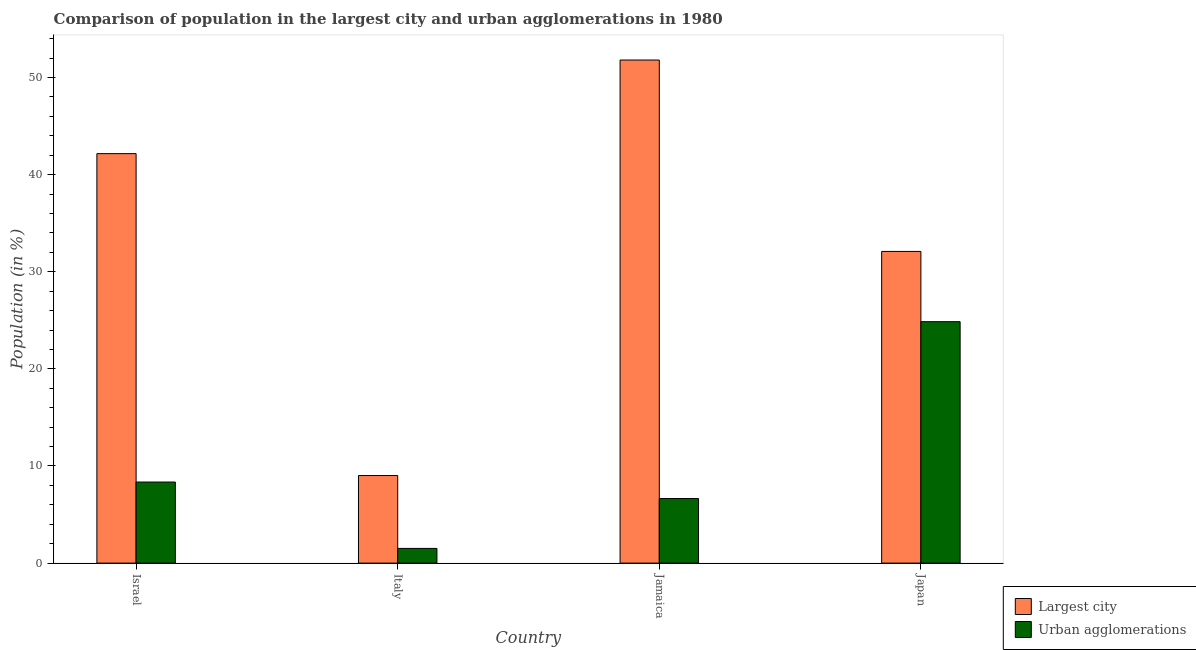How many different coloured bars are there?
Keep it short and to the point. 2. What is the label of the 1st group of bars from the left?
Provide a short and direct response. Israel. In how many cases, is the number of bars for a given country not equal to the number of legend labels?
Give a very brief answer. 0. What is the population in urban agglomerations in Jamaica?
Offer a very short reply. 6.65. Across all countries, what is the maximum population in urban agglomerations?
Offer a terse response. 24.86. Across all countries, what is the minimum population in the largest city?
Provide a succinct answer. 9.02. In which country was the population in urban agglomerations maximum?
Your answer should be compact. Japan. What is the total population in urban agglomerations in the graph?
Your answer should be very brief. 41.36. What is the difference between the population in the largest city in Israel and that in Jamaica?
Offer a very short reply. -9.64. What is the difference between the population in urban agglomerations in Italy and the population in the largest city in Japan?
Offer a very short reply. -30.58. What is the average population in urban agglomerations per country?
Your response must be concise. 10.34. What is the difference between the population in the largest city and population in urban agglomerations in Italy?
Your answer should be compact. 7.5. In how many countries, is the population in the largest city greater than 20 %?
Ensure brevity in your answer.  3. What is the ratio of the population in urban agglomerations in Italy to that in Jamaica?
Offer a very short reply. 0.23. What is the difference between the highest and the second highest population in urban agglomerations?
Your response must be concise. 16.51. What is the difference between the highest and the lowest population in urban agglomerations?
Provide a short and direct response. 23.35. Is the sum of the population in urban agglomerations in Israel and Japan greater than the maximum population in the largest city across all countries?
Provide a succinct answer. No. What does the 1st bar from the left in Italy represents?
Your answer should be compact. Largest city. What does the 1st bar from the right in Jamaica represents?
Give a very brief answer. Urban agglomerations. How many countries are there in the graph?
Your answer should be compact. 4. Are the values on the major ticks of Y-axis written in scientific E-notation?
Provide a succinct answer. No. Does the graph contain grids?
Your answer should be very brief. No. How many legend labels are there?
Provide a succinct answer. 2. What is the title of the graph?
Your response must be concise. Comparison of population in the largest city and urban agglomerations in 1980. Does "Secondary" appear as one of the legend labels in the graph?
Give a very brief answer. No. What is the label or title of the X-axis?
Make the answer very short. Country. What is the Population (in %) of Largest city in Israel?
Provide a short and direct response. 42.16. What is the Population (in %) in Urban agglomerations in Israel?
Give a very brief answer. 8.35. What is the Population (in %) in Largest city in Italy?
Offer a very short reply. 9.02. What is the Population (in %) in Urban agglomerations in Italy?
Your answer should be very brief. 1.51. What is the Population (in %) of Largest city in Jamaica?
Provide a succinct answer. 51.8. What is the Population (in %) of Urban agglomerations in Jamaica?
Your answer should be compact. 6.65. What is the Population (in %) in Largest city in Japan?
Keep it short and to the point. 32.09. What is the Population (in %) of Urban agglomerations in Japan?
Provide a short and direct response. 24.86. Across all countries, what is the maximum Population (in %) in Largest city?
Keep it short and to the point. 51.8. Across all countries, what is the maximum Population (in %) in Urban agglomerations?
Your answer should be compact. 24.86. Across all countries, what is the minimum Population (in %) in Largest city?
Your answer should be very brief. 9.02. Across all countries, what is the minimum Population (in %) of Urban agglomerations?
Provide a short and direct response. 1.51. What is the total Population (in %) of Largest city in the graph?
Provide a short and direct response. 135.07. What is the total Population (in %) of Urban agglomerations in the graph?
Ensure brevity in your answer.  41.36. What is the difference between the Population (in %) in Largest city in Israel and that in Italy?
Keep it short and to the point. 33.15. What is the difference between the Population (in %) in Urban agglomerations in Israel and that in Italy?
Provide a succinct answer. 6.83. What is the difference between the Population (in %) of Largest city in Israel and that in Jamaica?
Ensure brevity in your answer.  -9.64. What is the difference between the Population (in %) in Urban agglomerations in Israel and that in Jamaica?
Keep it short and to the point. 1.7. What is the difference between the Population (in %) of Largest city in Israel and that in Japan?
Offer a terse response. 10.07. What is the difference between the Population (in %) in Urban agglomerations in Israel and that in Japan?
Give a very brief answer. -16.51. What is the difference between the Population (in %) of Largest city in Italy and that in Jamaica?
Offer a very short reply. -42.78. What is the difference between the Population (in %) in Urban agglomerations in Italy and that in Jamaica?
Your answer should be compact. -5.14. What is the difference between the Population (in %) in Largest city in Italy and that in Japan?
Provide a succinct answer. -23.08. What is the difference between the Population (in %) of Urban agglomerations in Italy and that in Japan?
Give a very brief answer. -23.35. What is the difference between the Population (in %) in Largest city in Jamaica and that in Japan?
Ensure brevity in your answer.  19.71. What is the difference between the Population (in %) of Urban agglomerations in Jamaica and that in Japan?
Provide a succinct answer. -18.21. What is the difference between the Population (in %) in Largest city in Israel and the Population (in %) in Urban agglomerations in Italy?
Provide a short and direct response. 40.65. What is the difference between the Population (in %) of Largest city in Israel and the Population (in %) of Urban agglomerations in Jamaica?
Keep it short and to the point. 35.51. What is the difference between the Population (in %) in Largest city in Israel and the Population (in %) in Urban agglomerations in Japan?
Your response must be concise. 17.3. What is the difference between the Population (in %) of Largest city in Italy and the Population (in %) of Urban agglomerations in Jamaica?
Offer a terse response. 2.37. What is the difference between the Population (in %) in Largest city in Italy and the Population (in %) in Urban agglomerations in Japan?
Give a very brief answer. -15.84. What is the difference between the Population (in %) of Largest city in Jamaica and the Population (in %) of Urban agglomerations in Japan?
Offer a terse response. 26.94. What is the average Population (in %) in Largest city per country?
Your answer should be compact. 33.77. What is the average Population (in %) in Urban agglomerations per country?
Your answer should be compact. 10.34. What is the difference between the Population (in %) of Largest city and Population (in %) of Urban agglomerations in Israel?
Offer a terse response. 33.82. What is the difference between the Population (in %) in Largest city and Population (in %) in Urban agglomerations in Italy?
Provide a short and direct response. 7.5. What is the difference between the Population (in %) of Largest city and Population (in %) of Urban agglomerations in Jamaica?
Provide a short and direct response. 45.15. What is the difference between the Population (in %) in Largest city and Population (in %) in Urban agglomerations in Japan?
Your answer should be compact. 7.23. What is the ratio of the Population (in %) in Largest city in Israel to that in Italy?
Your response must be concise. 4.68. What is the ratio of the Population (in %) in Urban agglomerations in Israel to that in Italy?
Provide a short and direct response. 5.52. What is the ratio of the Population (in %) of Largest city in Israel to that in Jamaica?
Your response must be concise. 0.81. What is the ratio of the Population (in %) of Urban agglomerations in Israel to that in Jamaica?
Offer a terse response. 1.26. What is the ratio of the Population (in %) in Largest city in Israel to that in Japan?
Your answer should be compact. 1.31. What is the ratio of the Population (in %) in Urban agglomerations in Israel to that in Japan?
Provide a succinct answer. 0.34. What is the ratio of the Population (in %) in Largest city in Italy to that in Jamaica?
Your response must be concise. 0.17. What is the ratio of the Population (in %) of Urban agglomerations in Italy to that in Jamaica?
Provide a short and direct response. 0.23. What is the ratio of the Population (in %) in Largest city in Italy to that in Japan?
Your response must be concise. 0.28. What is the ratio of the Population (in %) of Urban agglomerations in Italy to that in Japan?
Your answer should be very brief. 0.06. What is the ratio of the Population (in %) in Largest city in Jamaica to that in Japan?
Offer a very short reply. 1.61. What is the ratio of the Population (in %) of Urban agglomerations in Jamaica to that in Japan?
Ensure brevity in your answer.  0.27. What is the difference between the highest and the second highest Population (in %) of Largest city?
Keep it short and to the point. 9.64. What is the difference between the highest and the second highest Population (in %) of Urban agglomerations?
Your response must be concise. 16.51. What is the difference between the highest and the lowest Population (in %) of Largest city?
Offer a terse response. 42.78. What is the difference between the highest and the lowest Population (in %) of Urban agglomerations?
Offer a terse response. 23.35. 